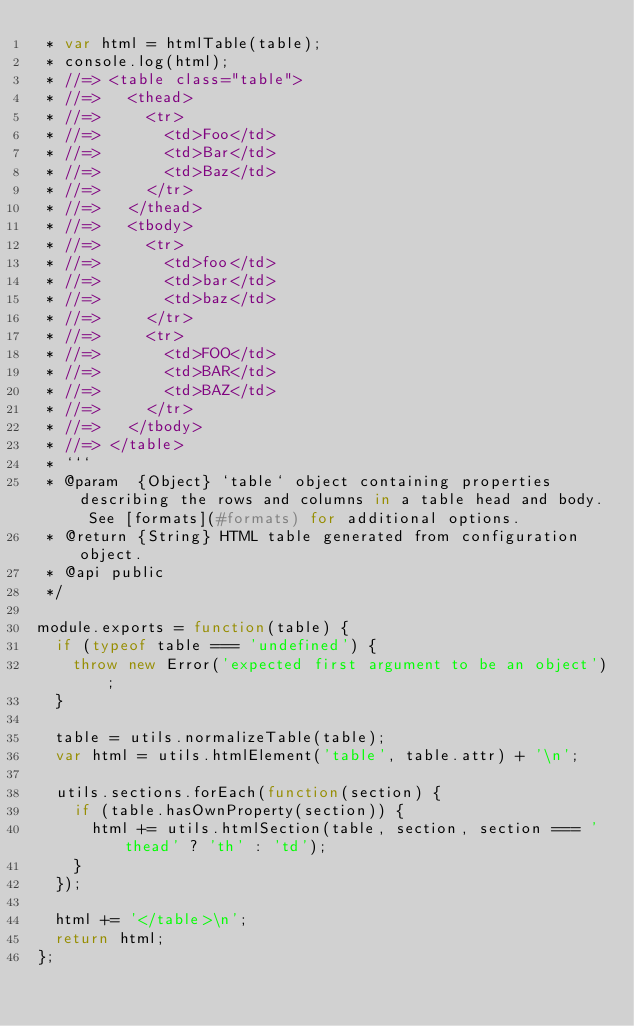<code> <loc_0><loc_0><loc_500><loc_500><_JavaScript_> * var html = htmlTable(table);
 * console.log(html);
 * //=> <table class="table">
 * //=>   <thead>
 * //=>     <tr>
 * //=>       <td>Foo</td>
 * //=>       <td>Bar</td>
 * //=>       <td>Baz</td>
 * //=>     </tr>
 * //=>   </thead>
 * //=>   <tbody>
 * //=>     <tr>
 * //=>       <td>foo</td>
 * //=>       <td>bar</td>
 * //=>       <td>baz</td>
 * //=>     </tr>
 * //=>     <tr>
 * //=>       <td>FOO</td>
 * //=>       <td>BAR</td>
 * //=>       <td>BAZ</td>
 * //=>     </tr>
 * //=>   </tbody>
 * //=> </table>
 * ```
 * @param  {Object} `table` object containing properties describing the rows and columns in a table head and body. See [formats](#formats) for additional options.
 * @return {String} HTML table generated from configuration object.
 * @api public
 */

module.exports = function(table) {
  if (typeof table === 'undefined') {
    throw new Error('expected first argument to be an object');
  }

  table = utils.normalizeTable(table);
  var html = utils.htmlElement('table', table.attr) + '\n';

  utils.sections.forEach(function(section) {
    if (table.hasOwnProperty(section)) {
      html += utils.htmlSection(table, section, section === 'thead' ? 'th' : 'td');
    }
  });

  html += '</table>\n';
  return html;
};

</code> 